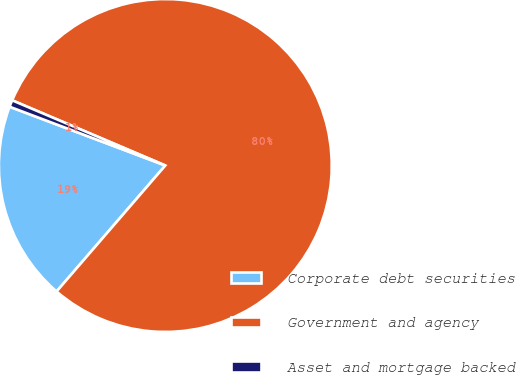Convert chart to OTSL. <chart><loc_0><loc_0><loc_500><loc_500><pie_chart><fcel>Corporate debt securities<fcel>Government and agency<fcel>Asset and mortgage backed<nl><fcel>19.41%<fcel>79.93%<fcel>0.66%<nl></chart> 